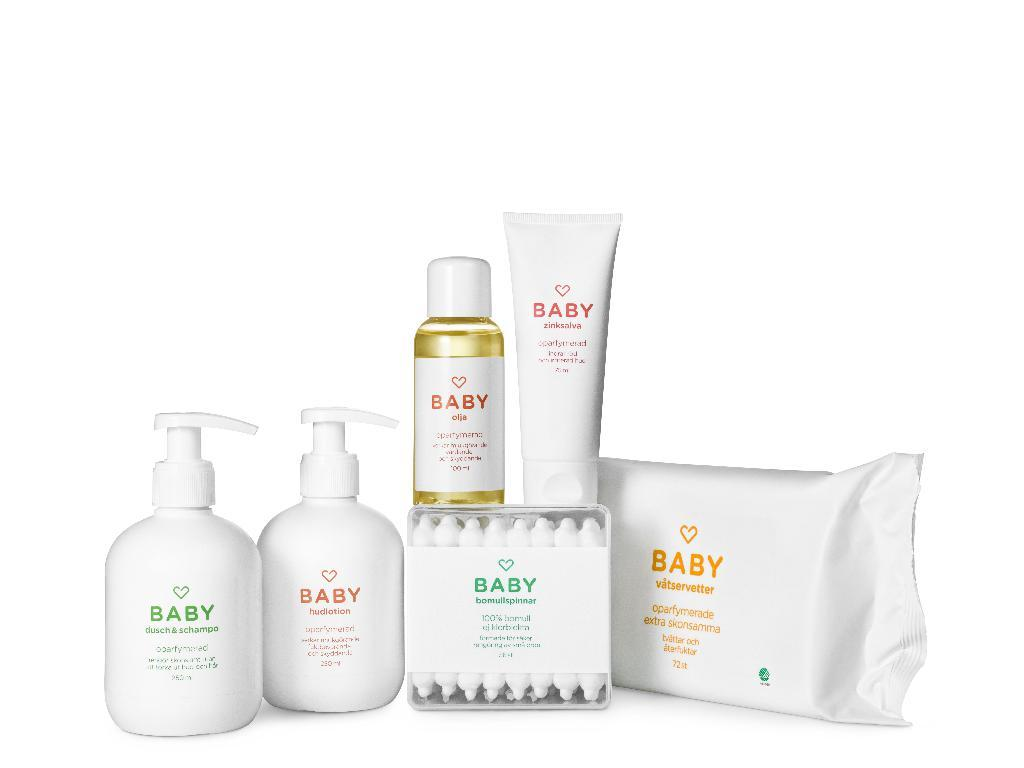<image>
Provide a brief description of the given image. Many products from the company Baby such as wipes. 